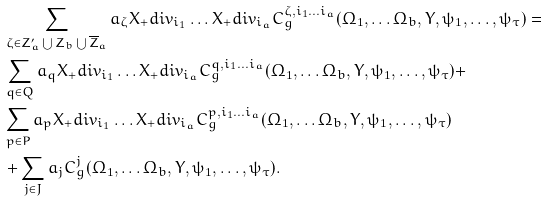<formula> <loc_0><loc_0><loc_500><loc_500>& \sum _ { \zeta \in Z ^ { \prime } _ { a } \bigcup Z _ { b } \bigcup \overline { Z } _ { a } } a _ { \zeta } X _ { + } d i v _ { i _ { 1 } } \dots X _ { + } d i v _ { i _ { a } } C ^ { \zeta , i _ { 1 } \dots i _ { a } } _ { g } ( \Omega _ { 1 } , \dots \Omega _ { b } , Y , \psi _ { 1 } , \dots , \psi _ { \tau } ) = \\ & \sum _ { q \in Q } a _ { q } X _ { + } d i v _ { i _ { 1 } } \dots X _ { + } d i v _ { i _ { a } } C ^ { q , i _ { 1 } \dots i _ { a } } _ { g } ( \Omega _ { 1 } , \dots \Omega _ { b } , Y , \psi _ { 1 } , \dots , \psi _ { \tau } ) + \\ & \sum _ { p \in P } a _ { p } X _ { + } d i v _ { i _ { 1 } } \dots X _ { + } d i v _ { i _ { a } } C ^ { p , i _ { 1 } \dots i _ { a } } _ { g } ( \Omega _ { 1 } , \dots \Omega _ { b } , Y , \psi _ { 1 } , \dots , \psi _ { \tau } ) \\ & + \sum _ { j \in J } a _ { j } C ^ { j } _ { g } ( \Omega _ { 1 } , \dots \Omega _ { b } , Y , \psi _ { 1 } , \dots , \psi _ { \tau } ) .</formula> 